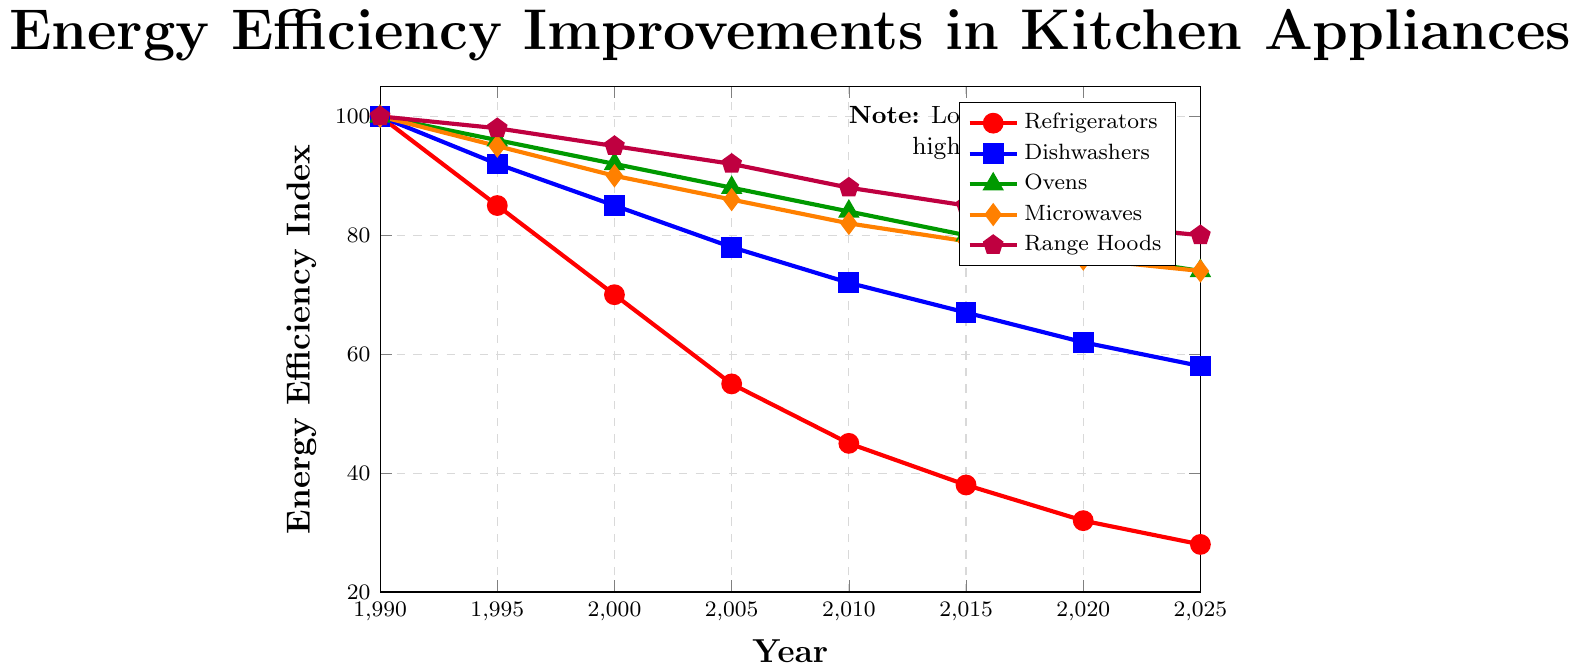Which appliance shows the greatest improvement in energy efficiency between 1990 and 2025? To find this, look for the appliance with the largest drop in its Energy Efficiency Index from 1990 to 2025. Refrigerators decrease from 100 to 28, Dishwashers from 100 to 58, Ovens from 100 to 74, Microwaves from 100 to 74, and Range Hoods from 100 to 80. The refrigerator shows the greatest improvement with a drop of 72 points.
Answer: Refrigerators In what year did dishwashers reach an Energy Efficiency Index of 67? Look for the year corresponding to the value 67 in the dishwashers' data. From the chart, in 2015, the dishwashers' index is at 67.
Answer: 2015 How much did the Energy Efficiency Index for ovens decrease between 1995 and 2010? Find the values for ovens in 1995 and 2010. The index decreases from 96 to 84. The difference is 96 - 84 = 12.
Answer: 12 Which appliance showed the least improvement in energy efficiency by 2025 compared to 1990? Compare the drop in the Energy Efficiency Index for each appliance between 1990 and 2025. Refrigerators improve by 72, Dishwashers by 42, Ovens by 26, Microwaves by 26, and Range Hoods by 20. Range Hoods show the least improvement.
Answer: Range Hoods In which year did all appliances experience a decrease in their Energy Efficiency Index compared to 1990? Check each appliance for a year where all of them show a lower index value than 1990 (which is 100 for each appliance). By 1995, each appliance (Refrigerators - 85, Dishwashers - 92, Ovens - 96, Microwaves - 95, Range Hoods - 98) shows lower values compared to 1990.
Answer: 1995 Calculate the average Energy Efficiency Index for microwaves from 1995 to 2025. List the values for microwaves from 1995 to 2025 (95, 90, 86, 82, 79, 76, 74). Calculate the average: (95 + 90 + 86 + 82 + 79 + 76 + 74) / 7 = 582 / 7 = 83.14.
Answer: 83.14 Between which two consecutive years did range hoods show the smallest improvement in energy efficiency? Calculate the change in energy efficiency for range hoods between consecutive years. 1990-1995: 2, 1995-2000: 3, 2000-2005: 3, 2005-2010: 4, 2010-2015: 3, 2015-2020: 3, 2020-2025: 2. The smallest improvements are 2 points, which occurred between 1990-1995 and 2020-2025.
Answer: 1990-1995 and 2020-2025 Which appliance had the highest Energy Efficiency Index in 2020? Look at the values for 2020 for all appliances: Refrigerators - 32, Dishwashers - 62, Ovens - 77, Microwaves - 76, Range Hoods - 82. Range Hoods had the highest index.
Answer: Range Hoods By how many points did the Energy Efficiency Index of refrigerators improve from 2000 to 2010? Find the values for refrigerators in 2000 and 2010. The index decreases from 70 to 45. Calculate the difference: 70 - 45 = 25.
Answer: 25 What trend can be observed from the Energy Efficiency Index for dishwashers from 1990 to 2025? Look at the dishwasher data points from 1990 to 2025 (100, 92, 85, 78, 72, 67, 62, 58). The Energy Efficiency Index consistently decreases, indicating that dishwashers are becoming more energy-efficient over time.
Answer: Decreasing 